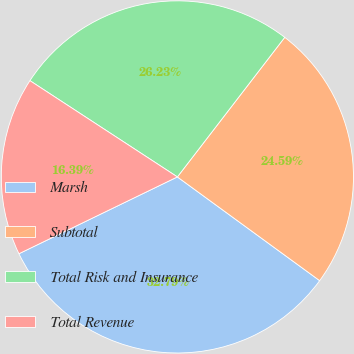Convert chart. <chart><loc_0><loc_0><loc_500><loc_500><pie_chart><fcel>Marsh<fcel>Subtotal<fcel>Total Risk and Insurance<fcel>Total Revenue<nl><fcel>32.79%<fcel>24.59%<fcel>26.23%<fcel>16.39%<nl></chart> 